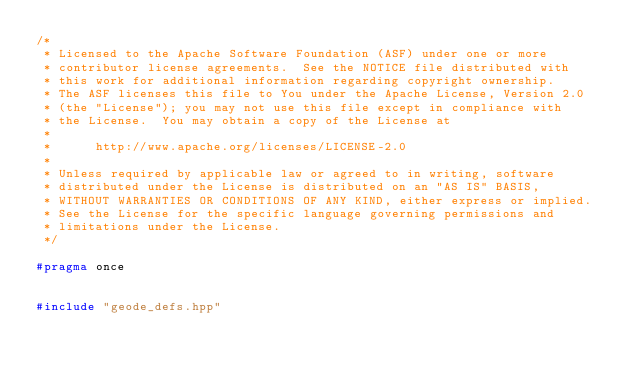<code> <loc_0><loc_0><loc_500><loc_500><_C++_>/*
 * Licensed to the Apache Software Foundation (ASF) under one or more
 * contributor license agreements.  See the NOTICE file distributed with
 * this work for additional information regarding copyright ownership.
 * The ASF licenses this file to You under the Apache License, Version 2.0
 * (the "License"); you may not use this file except in compliance with
 * the License.  You may obtain a copy of the License at
 *
 *      http://www.apache.org/licenses/LICENSE-2.0
 *
 * Unless required by applicable law or agreed to in writing, software
 * distributed under the License is distributed on an "AS IS" BASIS,
 * WITHOUT WARRANTIES OR CONDITIONS OF ANY KIND, either express or implied.
 * See the License for the specific language governing permissions and
 * limitations under the License.
 */

#pragma once


#include "geode_defs.hpp"</code> 